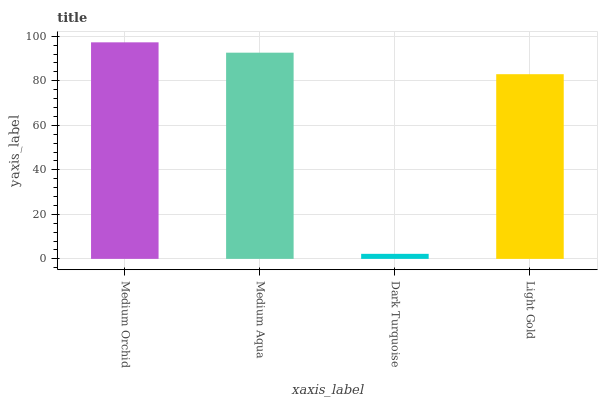Is Medium Aqua the minimum?
Answer yes or no. No. Is Medium Aqua the maximum?
Answer yes or no. No. Is Medium Orchid greater than Medium Aqua?
Answer yes or no. Yes. Is Medium Aqua less than Medium Orchid?
Answer yes or no. Yes. Is Medium Aqua greater than Medium Orchid?
Answer yes or no. No. Is Medium Orchid less than Medium Aqua?
Answer yes or no. No. Is Medium Aqua the high median?
Answer yes or no. Yes. Is Light Gold the low median?
Answer yes or no. Yes. Is Dark Turquoise the high median?
Answer yes or no. No. Is Dark Turquoise the low median?
Answer yes or no. No. 